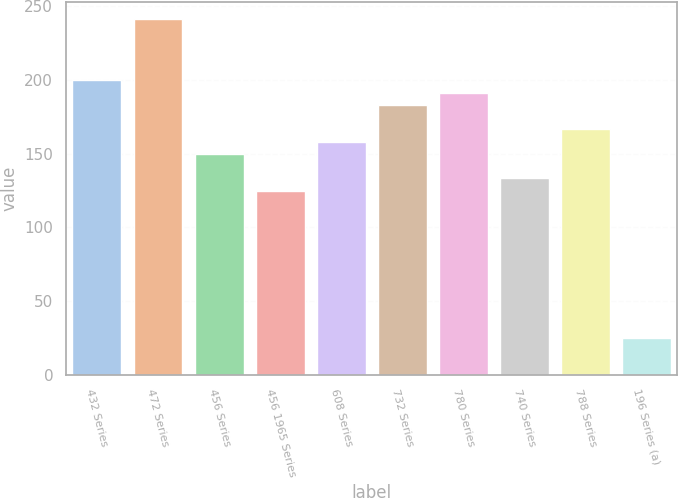Convert chart to OTSL. <chart><loc_0><loc_0><loc_500><loc_500><bar_chart><fcel>432 Series<fcel>472 Series<fcel>456 Series<fcel>456 1965 Series<fcel>608 Series<fcel>732 Series<fcel>780 Series<fcel>740 Series<fcel>788 Series<fcel>196 Series (a)<nl><fcel>199.6<fcel>241.1<fcel>149.8<fcel>124.9<fcel>158.1<fcel>183<fcel>191.3<fcel>133.2<fcel>166.4<fcel>25<nl></chart> 